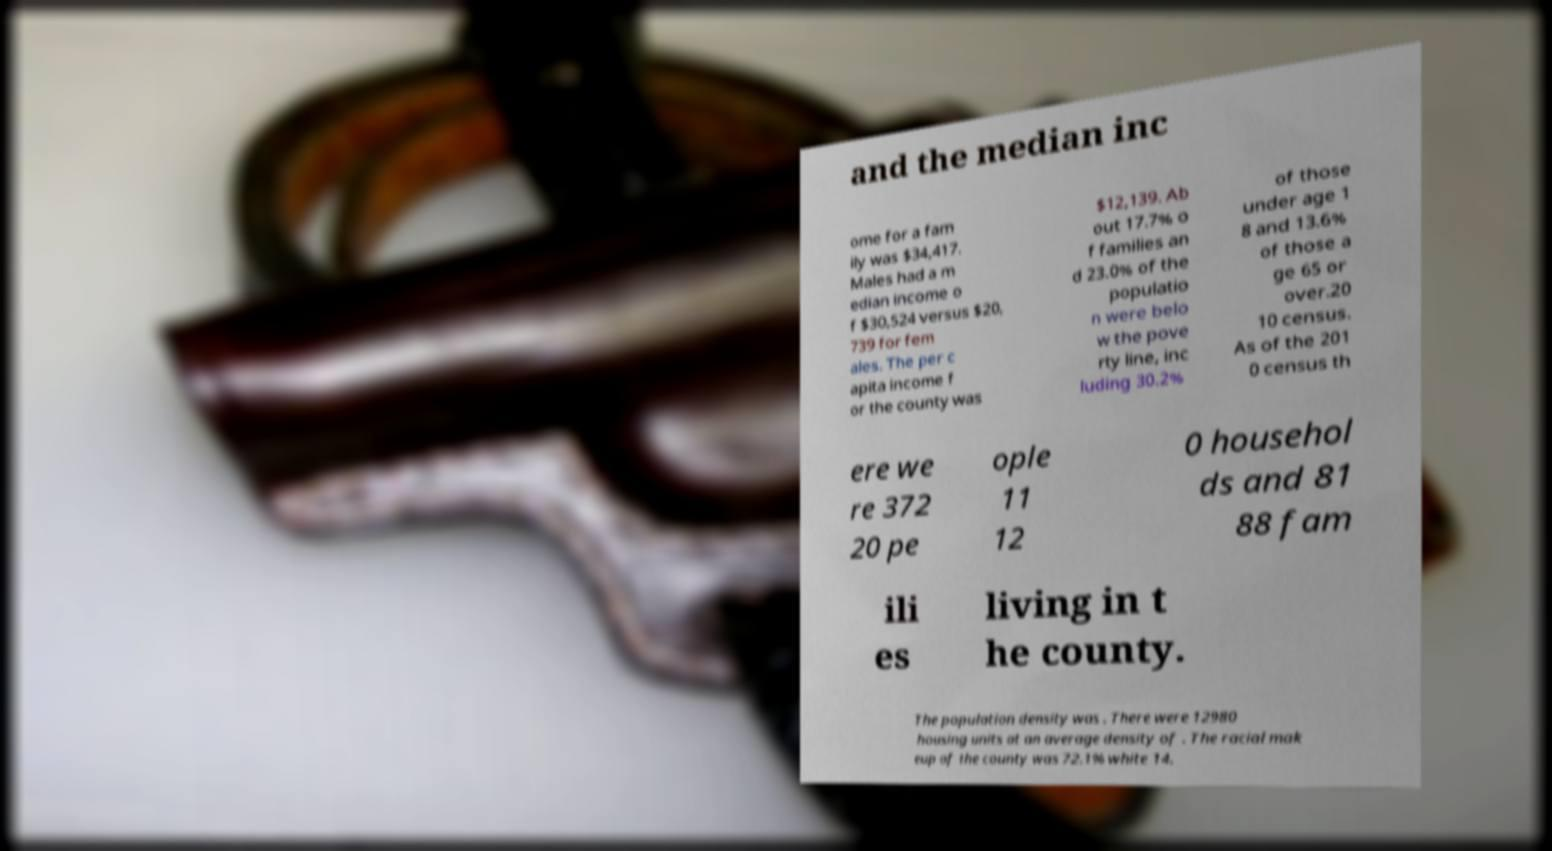I need the written content from this picture converted into text. Can you do that? and the median inc ome for a fam ily was $34,417. Males had a m edian income o f $30,524 versus $20, 739 for fem ales. The per c apita income f or the county was $12,139. Ab out 17.7% o f families an d 23.0% of the populatio n were belo w the pove rty line, inc luding 30.2% of those under age 1 8 and 13.6% of those a ge 65 or over.20 10 census. As of the 201 0 census th ere we re 372 20 pe ople 11 12 0 househol ds and 81 88 fam ili es living in t he county. The population density was . There were 12980 housing units at an average density of . The racial mak eup of the county was 72.1% white 14. 